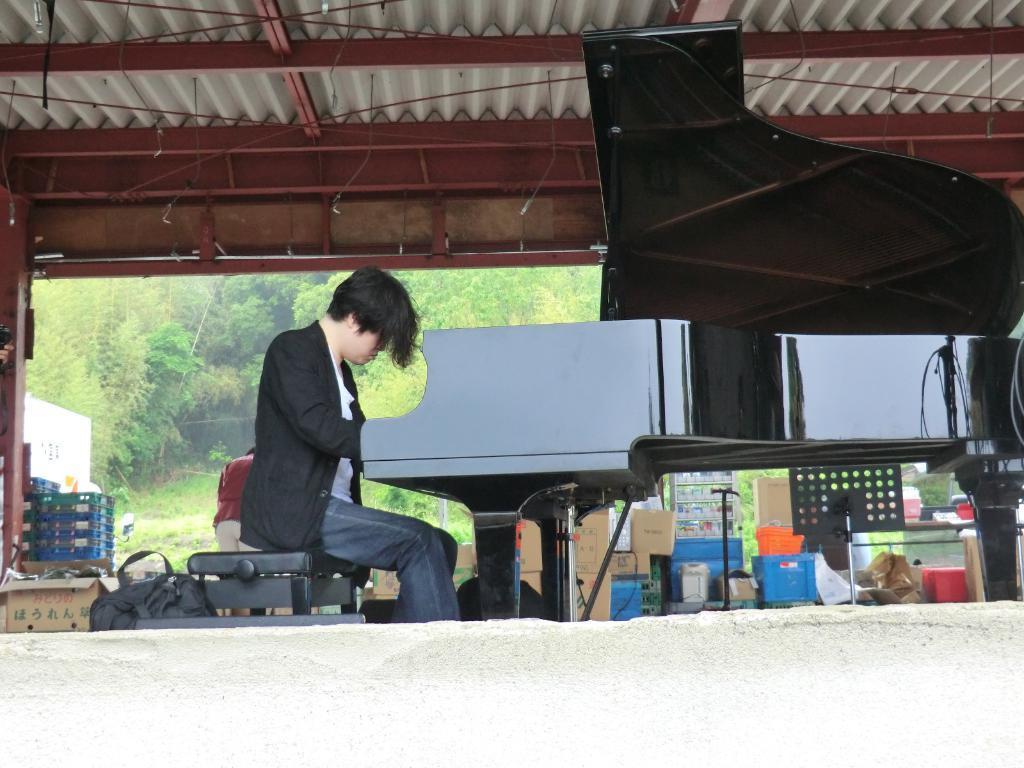Could you give a brief overview of what you see in this image? in the picture we can see person sitting on a table and playing the piano,we can also see different different items present near the person,we can also see another person a little bit far away from the person sitting on the table. 